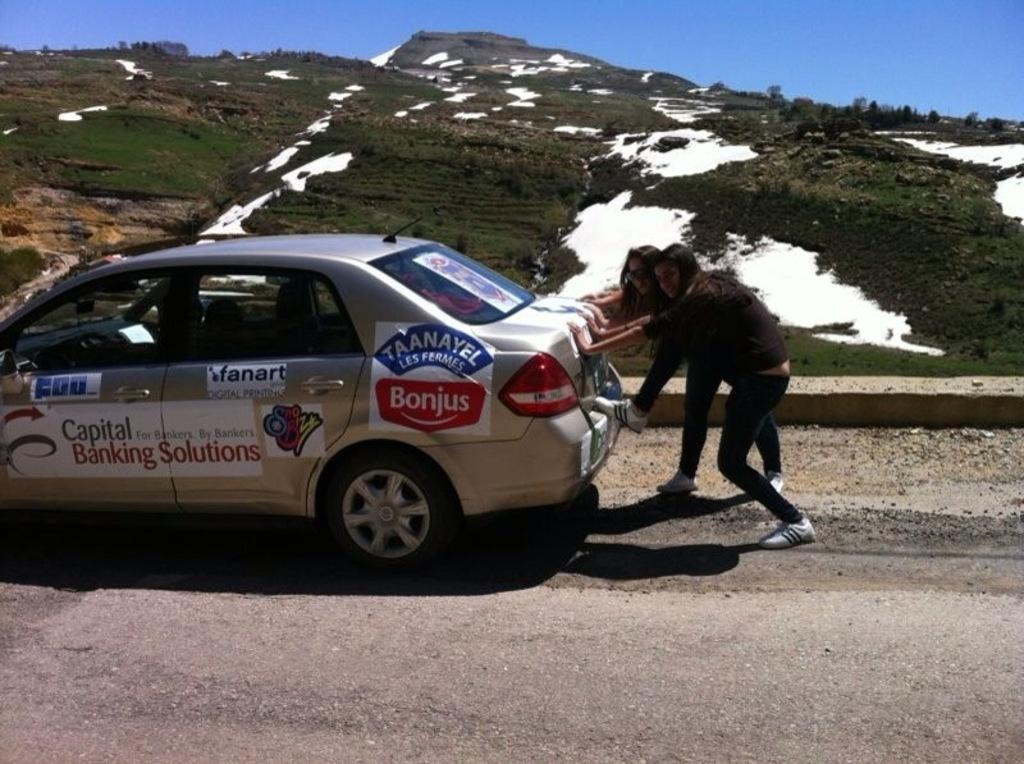What is the main subject of the image? The main subject of the image is a car. Are there any people visible in the image? Yes, two persons are visible from the back side of the car. What type of terrain can be seen in the image? There is a hill visible in the image. What is visible in the background of the image? The sky is visible in the image. What is the chance of finding a doctor at the seashore in the image? There is no mention of a doctor or a seashore in the image, so it is not possible to determine the chance of finding a doctor at the seashore. 